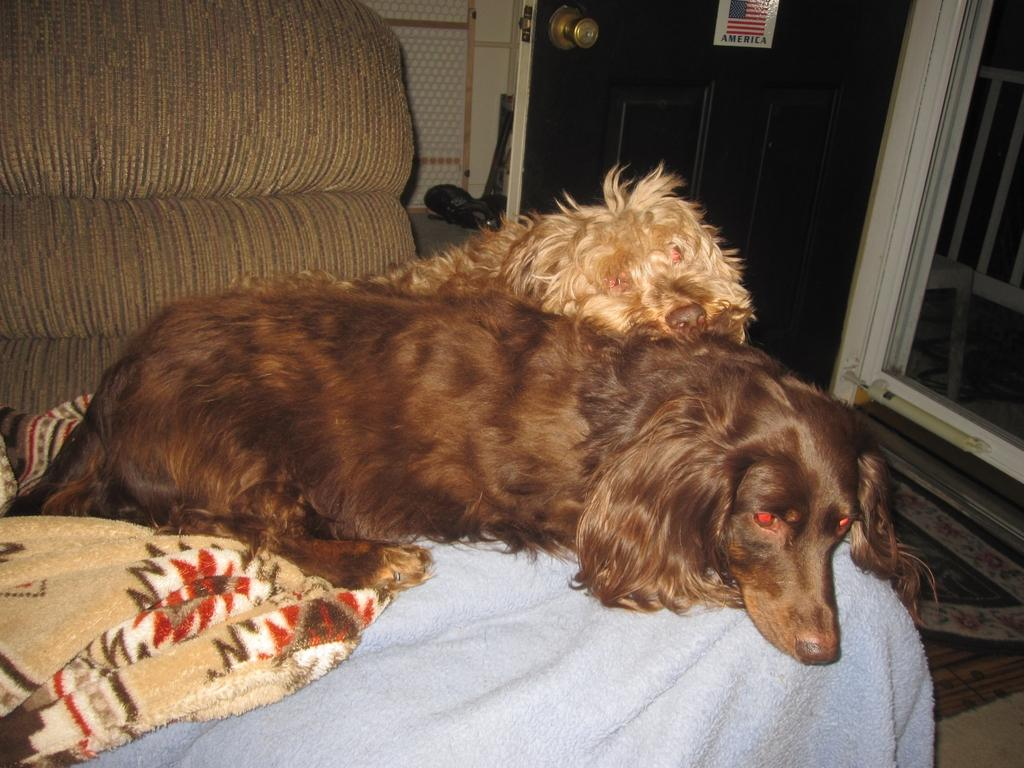How many dogs are in the image? There are two dogs in the image. Where are the dogs located? The dogs are on a couch. What can be seen in the background of the image? There is a door visible in the background of the image. What condition are the girls in the image? There are no girls present in the image; it features two dogs on a couch. What type of trade is being conducted in the image? There is no trade being conducted in the image; it features two dogs on a couch. 